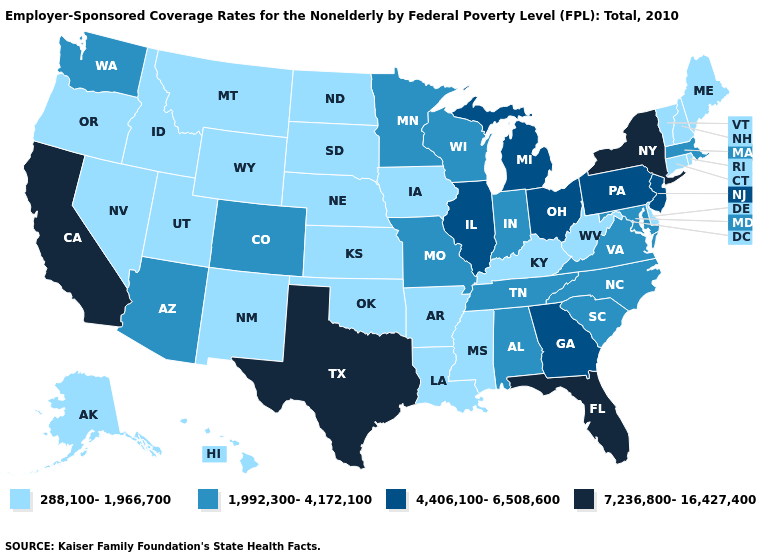What is the highest value in the MidWest ?
Quick response, please. 4,406,100-6,508,600. Does Georgia have the lowest value in the USA?
Short answer required. No. Among the states that border Louisiana , does Arkansas have the lowest value?
Quick response, please. Yes. Is the legend a continuous bar?
Keep it brief. No. Does the first symbol in the legend represent the smallest category?
Answer briefly. Yes. Does the map have missing data?
Concise answer only. No. What is the lowest value in states that border Arizona?
Answer briefly. 288,100-1,966,700. Name the states that have a value in the range 288,100-1,966,700?
Give a very brief answer. Alaska, Arkansas, Connecticut, Delaware, Hawaii, Idaho, Iowa, Kansas, Kentucky, Louisiana, Maine, Mississippi, Montana, Nebraska, Nevada, New Hampshire, New Mexico, North Dakota, Oklahoma, Oregon, Rhode Island, South Dakota, Utah, Vermont, West Virginia, Wyoming. Name the states that have a value in the range 7,236,800-16,427,400?
Keep it brief. California, Florida, New York, Texas. Does Pennsylvania have a lower value than Texas?
Be succinct. Yes. Which states have the lowest value in the USA?
Write a very short answer. Alaska, Arkansas, Connecticut, Delaware, Hawaii, Idaho, Iowa, Kansas, Kentucky, Louisiana, Maine, Mississippi, Montana, Nebraska, Nevada, New Hampshire, New Mexico, North Dakota, Oklahoma, Oregon, Rhode Island, South Dakota, Utah, Vermont, West Virginia, Wyoming. What is the value of Idaho?
Concise answer only. 288,100-1,966,700. Name the states that have a value in the range 1,992,300-4,172,100?
Quick response, please. Alabama, Arizona, Colorado, Indiana, Maryland, Massachusetts, Minnesota, Missouri, North Carolina, South Carolina, Tennessee, Virginia, Washington, Wisconsin. Name the states that have a value in the range 7,236,800-16,427,400?
Be succinct. California, Florida, New York, Texas. Name the states that have a value in the range 7,236,800-16,427,400?
Give a very brief answer. California, Florida, New York, Texas. 